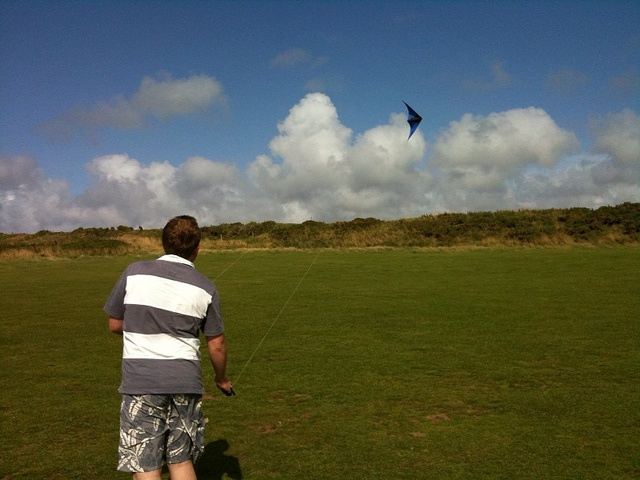Describe the objects in this image and their specific colors. I can see people in darkblue, gray, ivory, and black tones and kite in darkblue, black, navy, and gray tones in this image. 